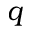Convert formula to latex. <formula><loc_0><loc_0><loc_500><loc_500>q</formula> 